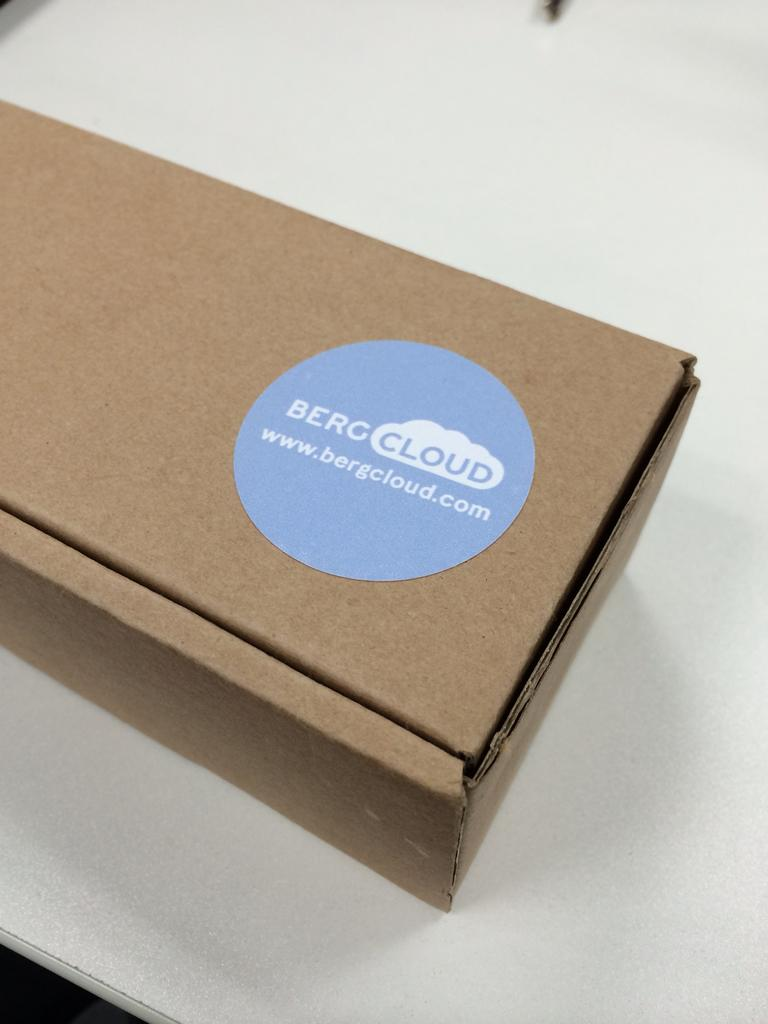Provide a one-sentence caption for the provided image. A cardboard box is labeled with the company name Bergcloud. 